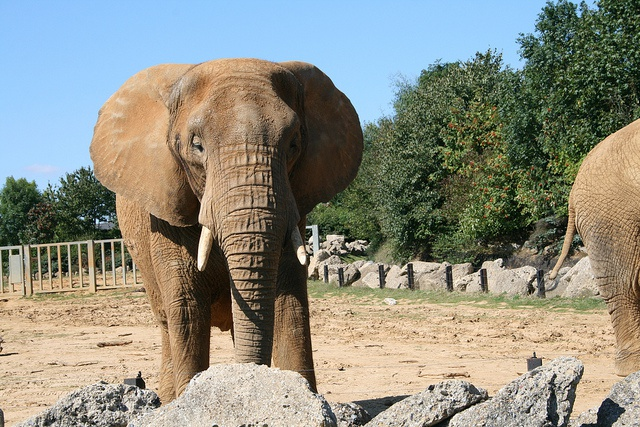Describe the objects in this image and their specific colors. I can see elephant in lightblue, black, and tan tones and elephant in lightblue, tan, and gray tones in this image. 